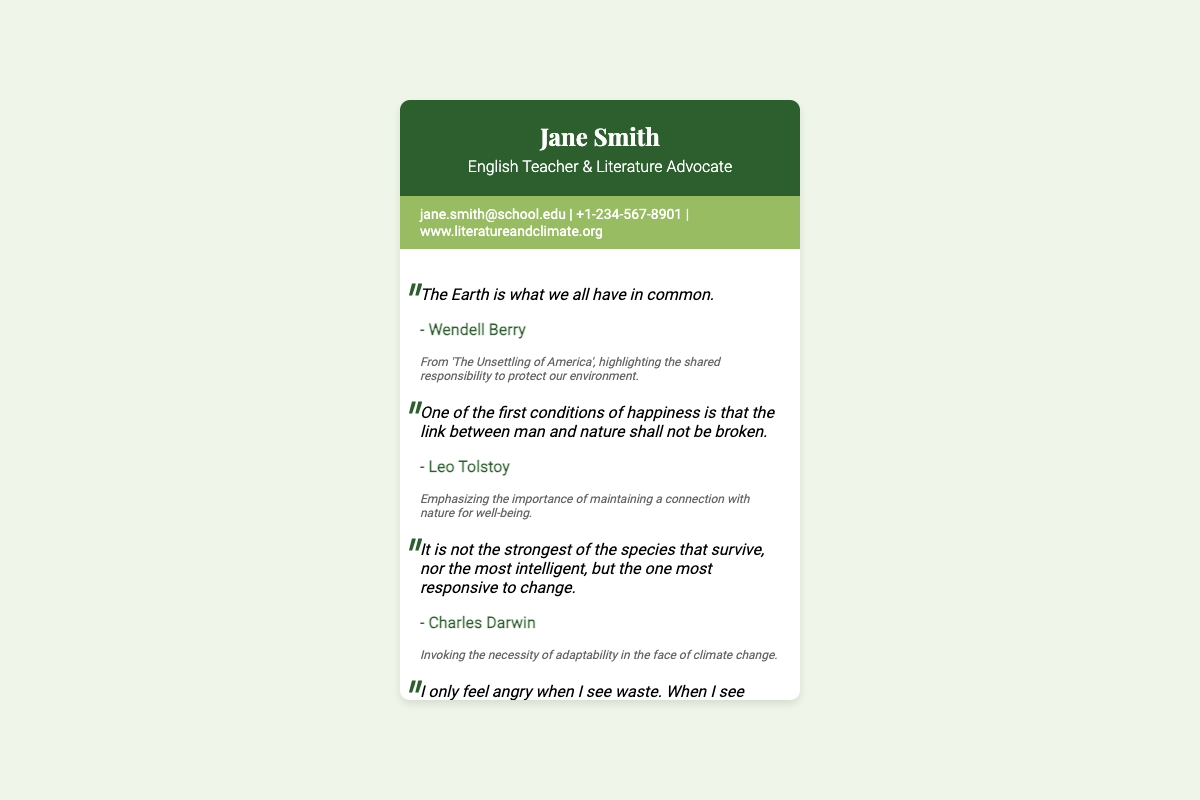What is the name on the business card? The name on the business card is prominently displayed at the top of the document.
Answer: Jane Smith What is the title of the person on the business card? The title is mentioned directly below the name in the header of the document.
Answer: English Teacher & Literature Advocate How many quotes about climate change are included? The total quotes are counted in the sections dedicated to quotes in the document.
Answer: Five Who is the author of the quote "The Earth is what we all have in common"? The author's name is stated immediately following the quote.
Answer: Wendell Berry What is the email address listed on the business card? The email address appears in the contact information section.
Answer: jane.smith@school.edu What is the background color of the header? The color is visually represented in the card's design and is specified in the document.
Answer: #2c5f2d Which quote emphasizes the link between man and nature? This requires locating the specific quote mentioning this concept.
Answer: "One of the first conditions of happiness is that the link between man and nature shall not be broken." What is the importance of the quote attributed to Charles Darwin? The reasoning is derived from the context provided after the quote.
Answer: Adaptability in climate change What type of document is this? The context and layout suggest the formal type of this document.
Answer: Business card 